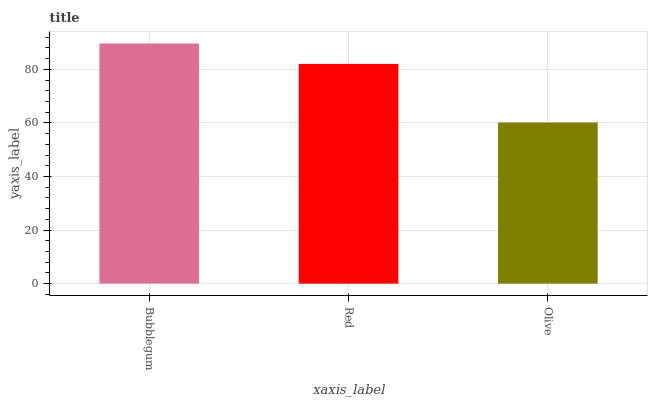Is Olive the minimum?
Answer yes or no. Yes. Is Bubblegum the maximum?
Answer yes or no. Yes. Is Red the minimum?
Answer yes or no. No. Is Red the maximum?
Answer yes or no. No. Is Bubblegum greater than Red?
Answer yes or no. Yes. Is Red less than Bubblegum?
Answer yes or no. Yes. Is Red greater than Bubblegum?
Answer yes or no. No. Is Bubblegum less than Red?
Answer yes or no. No. Is Red the high median?
Answer yes or no. Yes. Is Red the low median?
Answer yes or no. Yes. Is Olive the high median?
Answer yes or no. No. Is Bubblegum the low median?
Answer yes or no. No. 